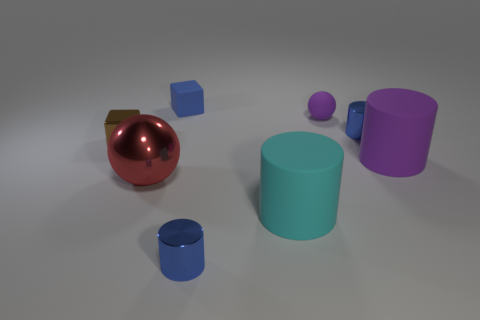How many cylinders are both left of the big purple matte object and in front of the small brown cube?
Offer a very short reply. 2. Does the big purple thing to the right of the cyan thing have the same shape as the small purple matte thing?
Provide a short and direct response. No. What is the material of the other block that is the same size as the blue rubber block?
Your answer should be compact. Metal. Are there an equal number of large red metal things that are on the left side of the small purple object and brown blocks on the right side of the brown shiny cube?
Offer a terse response. No. How many big purple matte objects are on the right side of the block that is on the right side of the small cube in front of the tiny rubber sphere?
Provide a succinct answer. 1. There is a matte block; is it the same color as the metallic thing right of the small purple object?
Offer a terse response. Yes. There is another cylinder that is the same material as the large cyan cylinder; what is its size?
Keep it short and to the point. Large. Is the number of rubber cubes behind the large cyan matte cylinder greater than the number of big gray things?
Make the answer very short. Yes. There is a blue cylinder that is behind the tiny blue object that is in front of the rubber cylinder that is in front of the purple rubber cylinder; what is it made of?
Provide a succinct answer. Metal. Is the brown block made of the same material as the sphere that is right of the blue matte block?
Offer a very short reply. No. 